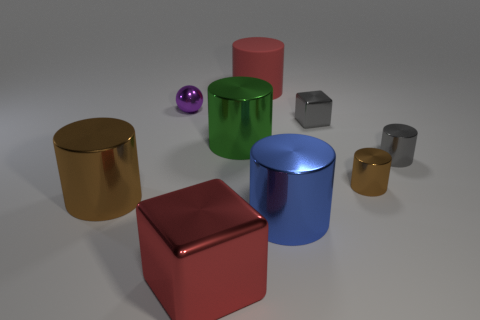Are there an equal number of cubes that are behind the red metallic thing and small gray shiny cylinders?
Give a very brief answer. Yes. Is the color of the large block to the left of the green object the same as the rubber cylinder?
Your response must be concise. Yes. What is the big object that is both behind the big brown object and in front of the ball made of?
Ensure brevity in your answer.  Metal. There is a big metal cylinder that is in front of the big brown metallic cylinder; is there a tiny purple ball that is in front of it?
Make the answer very short. No. Does the large green cylinder have the same material as the large red cylinder?
Provide a short and direct response. No. There is a big metal thing that is right of the large red block and left of the blue shiny thing; what is its shape?
Ensure brevity in your answer.  Cylinder. There is a red object behind the metal cylinder on the left side of the purple ball; how big is it?
Keep it short and to the point. Large. What number of purple metallic objects have the same shape as the big brown object?
Your answer should be very brief. 0. Does the large block have the same color as the matte cylinder?
Offer a terse response. Yes. Is there anything else that is the same shape as the purple object?
Your answer should be compact. No. 